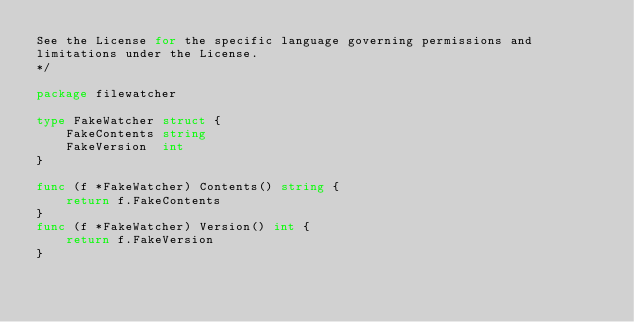Convert code to text. <code><loc_0><loc_0><loc_500><loc_500><_Go_>See the License for the specific language governing permissions and
limitations under the License.
*/

package filewatcher

type FakeWatcher struct {
	FakeContents string
	FakeVersion  int
}

func (f *FakeWatcher) Contents() string {
	return f.FakeContents
}
func (f *FakeWatcher) Version() int {
	return f.FakeVersion
}
</code> 